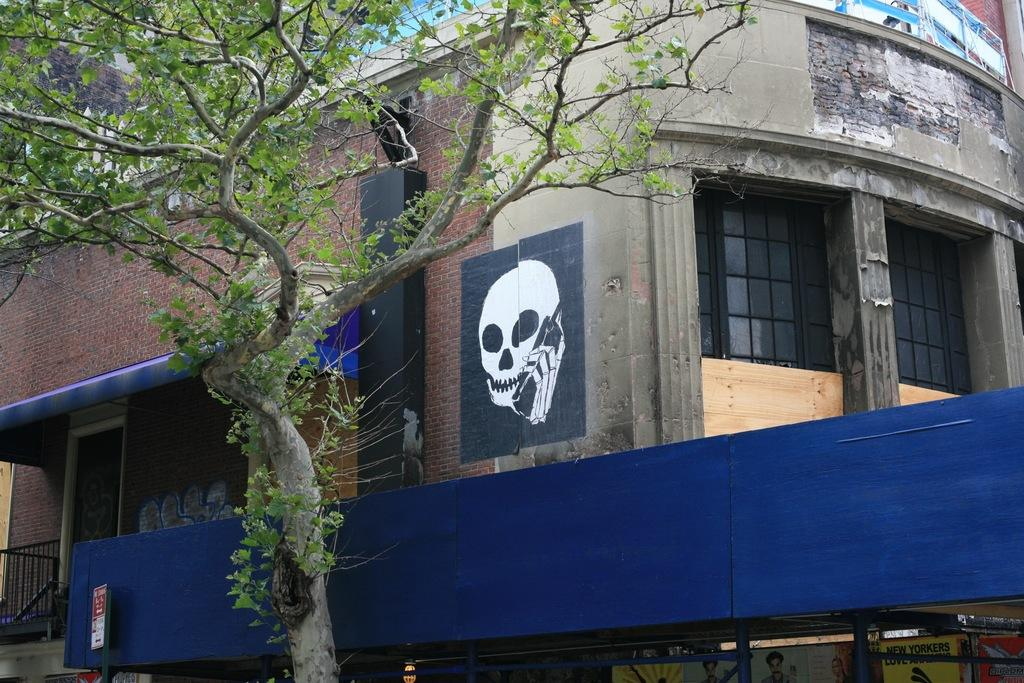What type of natural element can be seen in the image? There is a tree in the image. What structure is located behind the tree? There is a building with windows behind the tree. What is depicted on the wall of the building? There is a painting on the wall of the building with a skull. What is the purpose of the door beside the painting? The door beside the painting provides access to the building. What feature is near the door for safety or support? There is a railing near the door. What type of lead can be seen on the throne in the image? There is no throne present in the image; it features a tree, a building, and a painting with a skull. What type of produce is growing on the tree in the image? The facts provided do not mention any specific type of produce growing on the tree. 